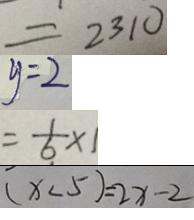Convert formula to latex. <formula><loc_0><loc_0><loc_500><loc_500>= 2 3 1 0 
 y = 2 
 = \frac { 1 } { 6 } \times 1 
 ( x < 5 ) = 2 x - 2</formula> 